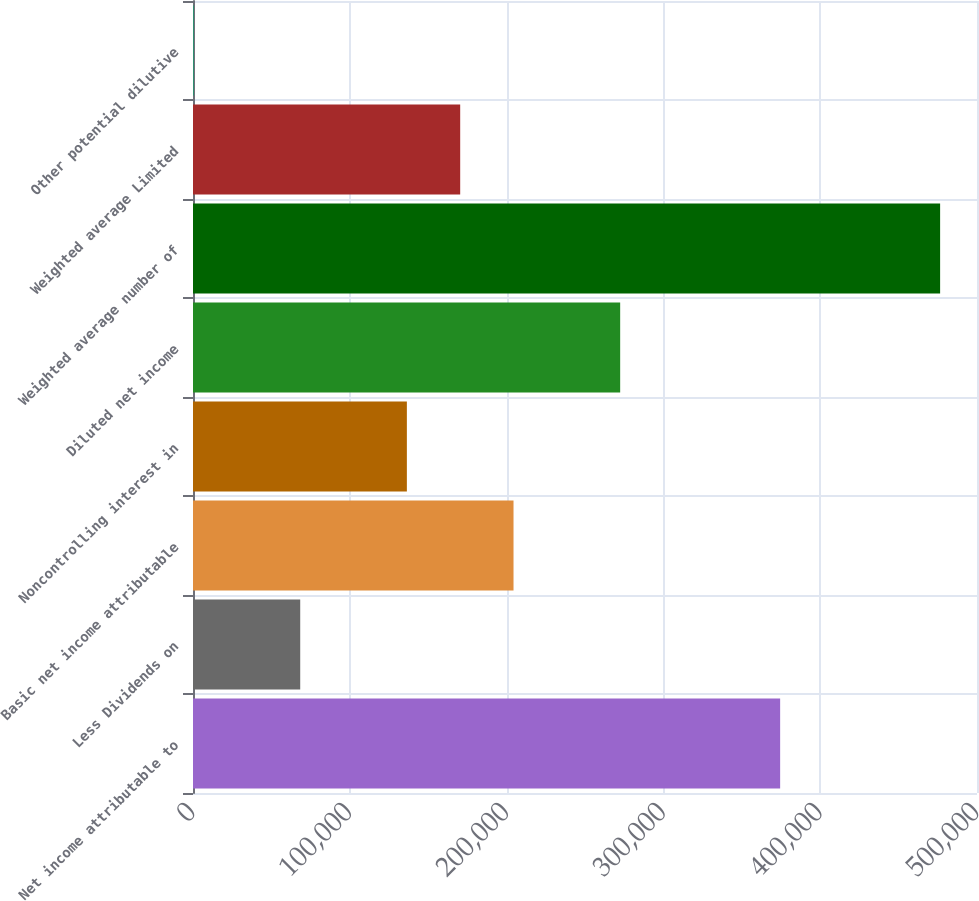<chart> <loc_0><loc_0><loc_500><loc_500><bar_chart><fcel>Net income attributable to<fcel>Less Dividends on<fcel>Basic net income attributable<fcel>Noncontrolling interest in<fcel>Diluted net income<fcel>Weighted average number of<fcel>Weighted average Limited<fcel>Other potential dilutive<nl><fcel>374454<fcel>68378<fcel>204412<fcel>136395<fcel>272429<fcel>476480<fcel>170404<fcel>361<nl></chart> 